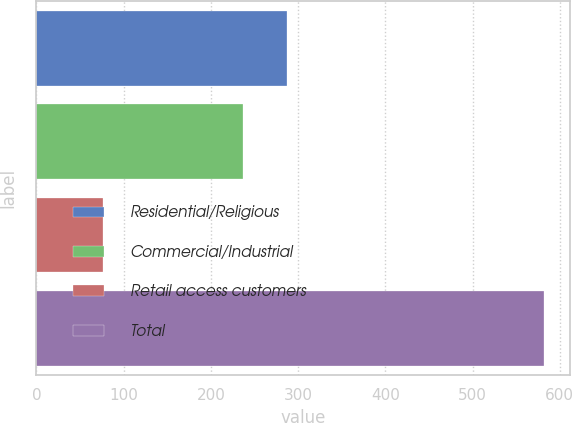Convert chart. <chart><loc_0><loc_0><loc_500><loc_500><bar_chart><fcel>Residential/Religious<fcel>Commercial/Industrial<fcel>Retail access customers<fcel>Total<nl><fcel>287.6<fcel>237<fcel>76<fcel>582<nl></chart> 